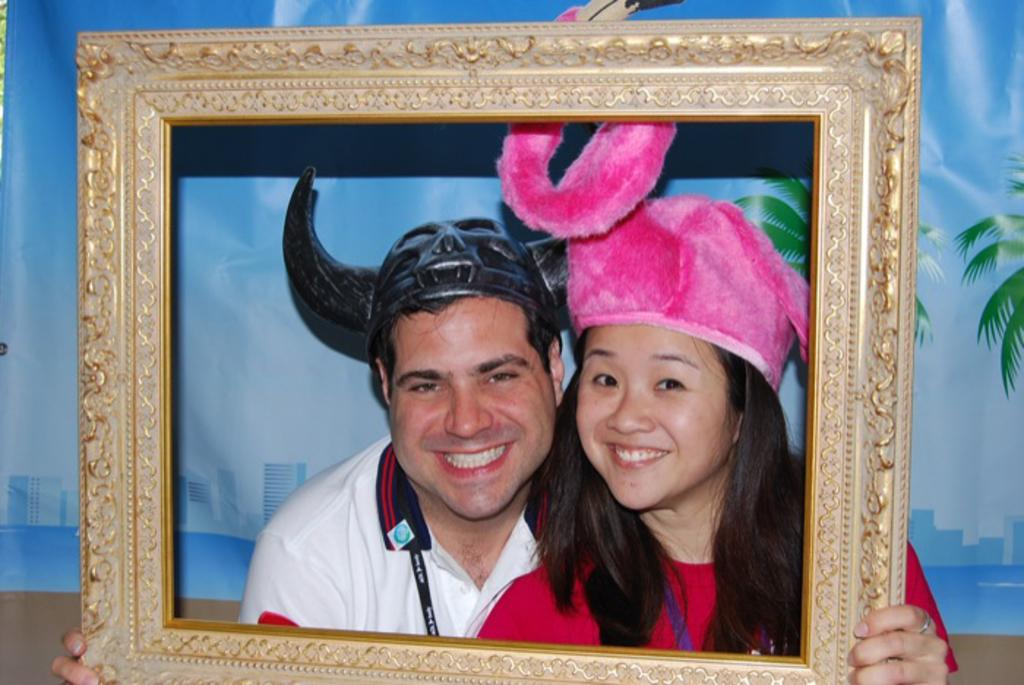How many people are present in the image? There are two people in the image, a man and a woman. What are the man and woman wearing on their heads? Both the man and woman are wearing caps. What are the man and woman holding in their hands? The man and woman are holding a frame in their hands. What can be seen in the background of the image? There is a banner in the background of the image, which contains pictures of trees and buildings. Can you tell me how many babies are visible in the image? There are no babies present in the image. What type of amusement park can be seen in the background of the image? There is no amusement park visible in the image; it features a banner with pictures of trees and buildings. 